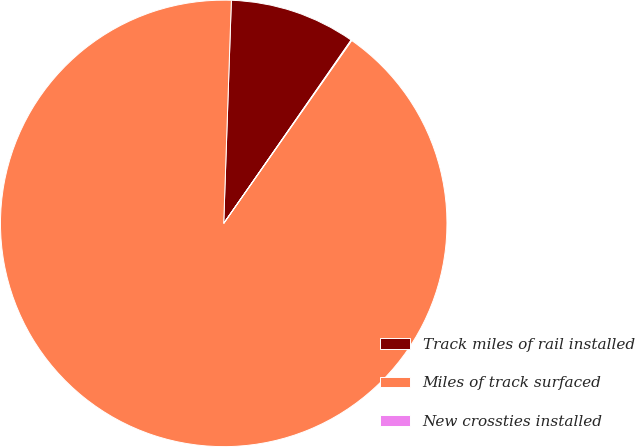Convert chart to OTSL. <chart><loc_0><loc_0><loc_500><loc_500><pie_chart><fcel>Track miles of rail installed<fcel>Miles of track surfaced<fcel>New crossties installed<nl><fcel>9.12%<fcel>90.83%<fcel>0.05%<nl></chart> 